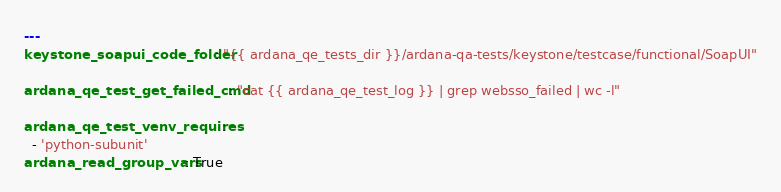<code> <loc_0><loc_0><loc_500><loc_500><_YAML_>---
keystone_soapui_code_folder: "{{ ardana_qe_tests_dir }}/ardana-qa-tests/keystone/testcase/functional/SoapUI"

ardana_qe_test_get_failed_cmd: "cat {{ ardana_qe_test_log }} | grep websso_failed | wc -l"

ardana_qe_test_venv_requires:
  - 'python-subunit'
ardana_read_group_vars: True
</code> 